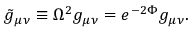Convert formula to latex. <formula><loc_0><loc_0><loc_500><loc_500>{ \tilde { g } } _ { \mu \nu } \equiv \Omega ^ { 2 } g _ { \mu \nu } = e ^ { - 2 \Phi } g _ { \mu \nu } .</formula> 